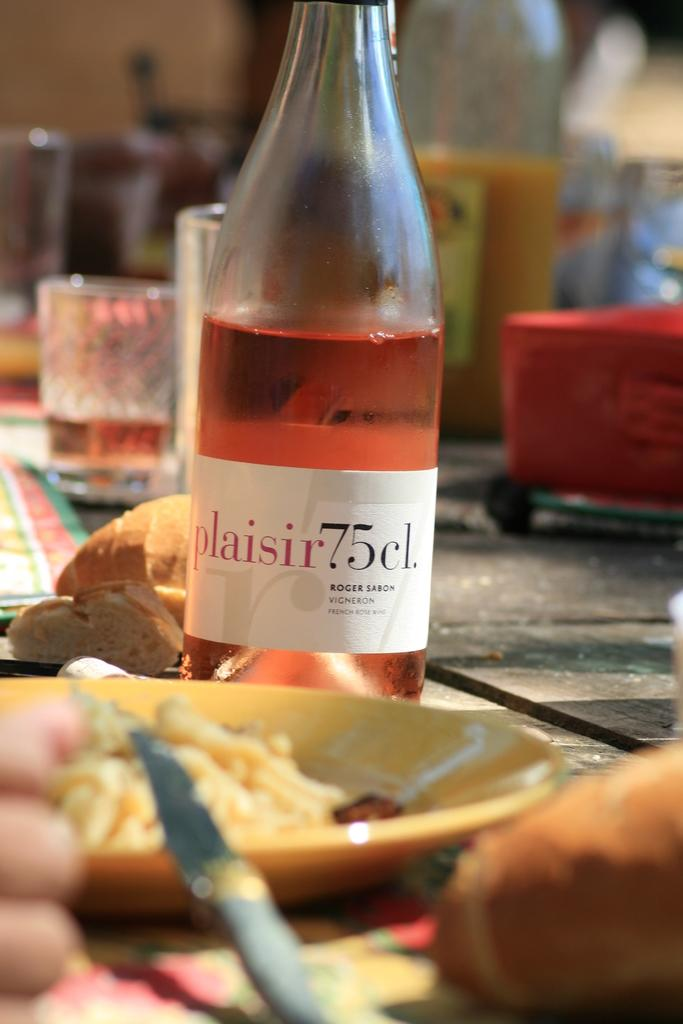Provide a one-sentence caption for the provided image. A half empty bottle of Roger Sabon Vigneron wine on a table. 